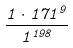<formula> <loc_0><loc_0><loc_500><loc_500>\frac { 1 \cdot 1 7 1 ^ { 9 } } { 1 ^ { 1 9 8 } }</formula> 